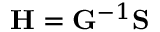Convert formula to latex. <formula><loc_0><loc_0><loc_500><loc_500>H = G ^ { - 1 } S</formula> 